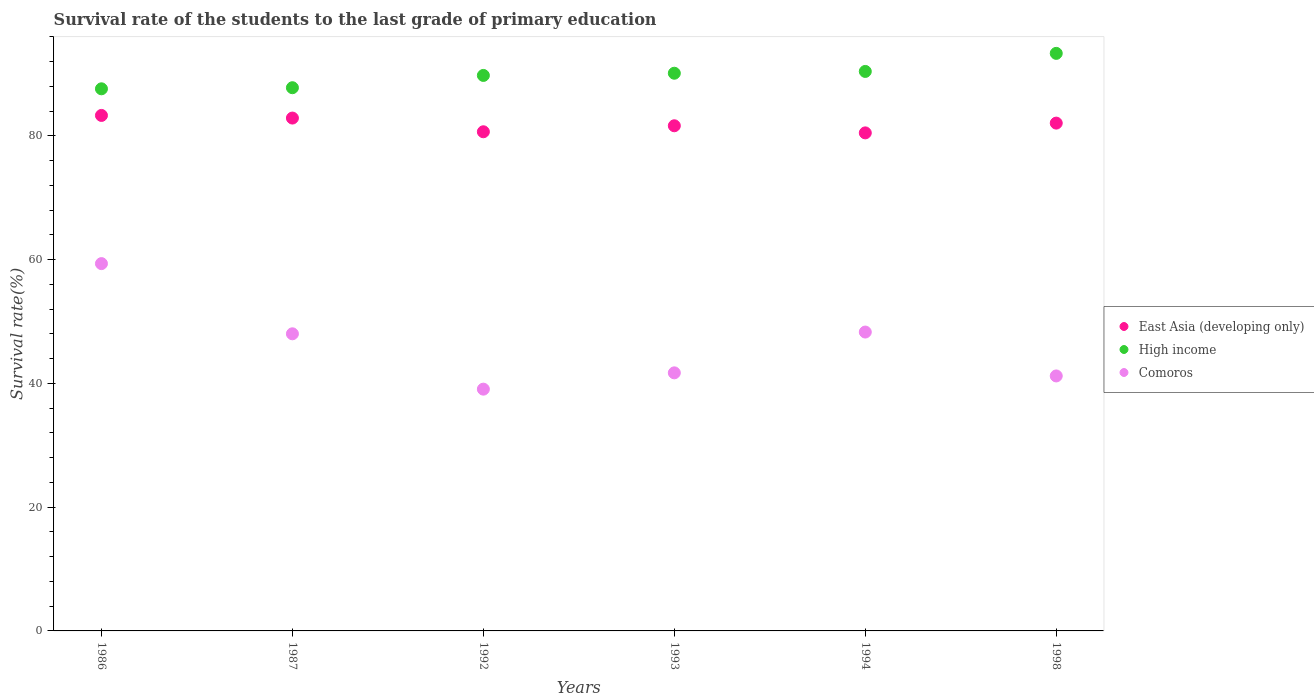What is the survival rate of the students in High income in 1986?
Offer a very short reply. 87.62. Across all years, what is the maximum survival rate of the students in High income?
Your answer should be very brief. 93.35. Across all years, what is the minimum survival rate of the students in East Asia (developing only)?
Ensure brevity in your answer.  80.5. In which year was the survival rate of the students in Comoros maximum?
Keep it short and to the point. 1986. What is the total survival rate of the students in East Asia (developing only) in the graph?
Your answer should be compact. 491.12. What is the difference between the survival rate of the students in East Asia (developing only) in 1987 and that in 1992?
Your answer should be very brief. 2.22. What is the difference between the survival rate of the students in High income in 1992 and the survival rate of the students in East Asia (developing only) in 1986?
Keep it short and to the point. 6.46. What is the average survival rate of the students in East Asia (developing only) per year?
Keep it short and to the point. 81.85. In the year 1986, what is the difference between the survival rate of the students in Comoros and survival rate of the students in East Asia (developing only)?
Offer a very short reply. -23.95. In how many years, is the survival rate of the students in East Asia (developing only) greater than 72 %?
Make the answer very short. 6. What is the ratio of the survival rate of the students in East Asia (developing only) in 1986 to that in 1992?
Make the answer very short. 1.03. Is the survival rate of the students in Comoros in 1987 less than that in 1998?
Provide a succinct answer. No. What is the difference between the highest and the second highest survival rate of the students in Comoros?
Offer a very short reply. 11.06. What is the difference between the highest and the lowest survival rate of the students in East Asia (developing only)?
Offer a very short reply. 2.82. In how many years, is the survival rate of the students in High income greater than the average survival rate of the students in High income taken over all years?
Your answer should be compact. 3. Is the sum of the survival rate of the students in Comoros in 1986 and 1992 greater than the maximum survival rate of the students in East Asia (developing only) across all years?
Offer a very short reply. Yes. Is it the case that in every year, the sum of the survival rate of the students in High income and survival rate of the students in Comoros  is greater than the survival rate of the students in East Asia (developing only)?
Ensure brevity in your answer.  Yes. What is the difference between two consecutive major ticks on the Y-axis?
Keep it short and to the point. 20. Does the graph contain any zero values?
Give a very brief answer. No. Does the graph contain grids?
Your response must be concise. No. How are the legend labels stacked?
Ensure brevity in your answer.  Vertical. What is the title of the graph?
Your response must be concise. Survival rate of the students to the last grade of primary education. What is the label or title of the Y-axis?
Keep it short and to the point. Survival rate(%). What is the Survival rate(%) in East Asia (developing only) in 1986?
Give a very brief answer. 83.32. What is the Survival rate(%) in High income in 1986?
Offer a very short reply. 87.62. What is the Survival rate(%) of Comoros in 1986?
Your answer should be compact. 59.37. What is the Survival rate(%) of East Asia (developing only) in 1987?
Keep it short and to the point. 82.89. What is the Survival rate(%) of High income in 1987?
Keep it short and to the point. 87.8. What is the Survival rate(%) of Comoros in 1987?
Offer a very short reply. 48.02. What is the Survival rate(%) of East Asia (developing only) in 1992?
Keep it short and to the point. 80.68. What is the Survival rate(%) of High income in 1992?
Your response must be concise. 89.79. What is the Survival rate(%) in Comoros in 1992?
Provide a succinct answer. 39.08. What is the Survival rate(%) of East Asia (developing only) in 1993?
Ensure brevity in your answer.  81.65. What is the Survival rate(%) of High income in 1993?
Your answer should be very brief. 90.14. What is the Survival rate(%) in Comoros in 1993?
Your answer should be very brief. 41.71. What is the Survival rate(%) in East Asia (developing only) in 1994?
Offer a very short reply. 80.5. What is the Survival rate(%) of High income in 1994?
Make the answer very short. 90.43. What is the Survival rate(%) in Comoros in 1994?
Give a very brief answer. 48.31. What is the Survival rate(%) of East Asia (developing only) in 1998?
Make the answer very short. 82.08. What is the Survival rate(%) of High income in 1998?
Offer a very short reply. 93.35. What is the Survival rate(%) of Comoros in 1998?
Provide a short and direct response. 41.21. Across all years, what is the maximum Survival rate(%) in East Asia (developing only)?
Your response must be concise. 83.32. Across all years, what is the maximum Survival rate(%) of High income?
Provide a succinct answer. 93.35. Across all years, what is the maximum Survival rate(%) of Comoros?
Your answer should be very brief. 59.37. Across all years, what is the minimum Survival rate(%) in East Asia (developing only)?
Give a very brief answer. 80.5. Across all years, what is the minimum Survival rate(%) in High income?
Give a very brief answer. 87.62. Across all years, what is the minimum Survival rate(%) of Comoros?
Offer a very short reply. 39.08. What is the total Survival rate(%) in East Asia (developing only) in the graph?
Make the answer very short. 491.12. What is the total Survival rate(%) of High income in the graph?
Your response must be concise. 539.14. What is the total Survival rate(%) of Comoros in the graph?
Ensure brevity in your answer.  277.7. What is the difference between the Survival rate(%) in East Asia (developing only) in 1986 and that in 1987?
Ensure brevity in your answer.  0.43. What is the difference between the Survival rate(%) in High income in 1986 and that in 1987?
Your answer should be compact. -0.18. What is the difference between the Survival rate(%) of Comoros in 1986 and that in 1987?
Your answer should be compact. 11.34. What is the difference between the Survival rate(%) of East Asia (developing only) in 1986 and that in 1992?
Offer a very short reply. 2.64. What is the difference between the Survival rate(%) in High income in 1986 and that in 1992?
Provide a succinct answer. -2.16. What is the difference between the Survival rate(%) of Comoros in 1986 and that in 1992?
Your response must be concise. 20.29. What is the difference between the Survival rate(%) of East Asia (developing only) in 1986 and that in 1993?
Offer a terse response. 1.67. What is the difference between the Survival rate(%) of High income in 1986 and that in 1993?
Offer a very short reply. -2.52. What is the difference between the Survival rate(%) in Comoros in 1986 and that in 1993?
Your answer should be compact. 17.66. What is the difference between the Survival rate(%) in East Asia (developing only) in 1986 and that in 1994?
Provide a succinct answer. 2.82. What is the difference between the Survival rate(%) in High income in 1986 and that in 1994?
Your answer should be compact. -2.81. What is the difference between the Survival rate(%) in Comoros in 1986 and that in 1994?
Provide a succinct answer. 11.06. What is the difference between the Survival rate(%) of East Asia (developing only) in 1986 and that in 1998?
Make the answer very short. 1.24. What is the difference between the Survival rate(%) of High income in 1986 and that in 1998?
Provide a succinct answer. -5.73. What is the difference between the Survival rate(%) of Comoros in 1986 and that in 1998?
Your answer should be compact. 18.16. What is the difference between the Survival rate(%) in East Asia (developing only) in 1987 and that in 1992?
Give a very brief answer. 2.22. What is the difference between the Survival rate(%) of High income in 1987 and that in 1992?
Offer a very short reply. -1.99. What is the difference between the Survival rate(%) in Comoros in 1987 and that in 1992?
Give a very brief answer. 8.95. What is the difference between the Survival rate(%) in East Asia (developing only) in 1987 and that in 1993?
Offer a very short reply. 1.24. What is the difference between the Survival rate(%) in High income in 1987 and that in 1993?
Keep it short and to the point. -2.34. What is the difference between the Survival rate(%) of Comoros in 1987 and that in 1993?
Provide a short and direct response. 6.31. What is the difference between the Survival rate(%) in East Asia (developing only) in 1987 and that in 1994?
Provide a succinct answer. 2.4. What is the difference between the Survival rate(%) in High income in 1987 and that in 1994?
Provide a succinct answer. -2.63. What is the difference between the Survival rate(%) of Comoros in 1987 and that in 1994?
Your answer should be very brief. -0.28. What is the difference between the Survival rate(%) in East Asia (developing only) in 1987 and that in 1998?
Ensure brevity in your answer.  0.82. What is the difference between the Survival rate(%) of High income in 1987 and that in 1998?
Your answer should be very brief. -5.55. What is the difference between the Survival rate(%) in Comoros in 1987 and that in 1998?
Keep it short and to the point. 6.81. What is the difference between the Survival rate(%) of East Asia (developing only) in 1992 and that in 1993?
Give a very brief answer. -0.97. What is the difference between the Survival rate(%) in High income in 1992 and that in 1993?
Offer a very short reply. -0.36. What is the difference between the Survival rate(%) of Comoros in 1992 and that in 1993?
Provide a succinct answer. -2.64. What is the difference between the Survival rate(%) in East Asia (developing only) in 1992 and that in 1994?
Ensure brevity in your answer.  0.18. What is the difference between the Survival rate(%) in High income in 1992 and that in 1994?
Your answer should be very brief. -0.65. What is the difference between the Survival rate(%) of Comoros in 1992 and that in 1994?
Provide a succinct answer. -9.23. What is the difference between the Survival rate(%) in East Asia (developing only) in 1992 and that in 1998?
Keep it short and to the point. -1.4. What is the difference between the Survival rate(%) in High income in 1992 and that in 1998?
Provide a succinct answer. -3.57. What is the difference between the Survival rate(%) in Comoros in 1992 and that in 1998?
Offer a terse response. -2.14. What is the difference between the Survival rate(%) in East Asia (developing only) in 1993 and that in 1994?
Provide a short and direct response. 1.15. What is the difference between the Survival rate(%) in High income in 1993 and that in 1994?
Provide a short and direct response. -0.29. What is the difference between the Survival rate(%) of Comoros in 1993 and that in 1994?
Your answer should be very brief. -6.59. What is the difference between the Survival rate(%) of East Asia (developing only) in 1993 and that in 1998?
Your answer should be compact. -0.43. What is the difference between the Survival rate(%) of High income in 1993 and that in 1998?
Offer a very short reply. -3.21. What is the difference between the Survival rate(%) of Comoros in 1993 and that in 1998?
Ensure brevity in your answer.  0.5. What is the difference between the Survival rate(%) in East Asia (developing only) in 1994 and that in 1998?
Your answer should be very brief. -1.58. What is the difference between the Survival rate(%) in High income in 1994 and that in 1998?
Provide a short and direct response. -2.92. What is the difference between the Survival rate(%) of Comoros in 1994 and that in 1998?
Offer a very short reply. 7.1. What is the difference between the Survival rate(%) in East Asia (developing only) in 1986 and the Survival rate(%) in High income in 1987?
Give a very brief answer. -4.48. What is the difference between the Survival rate(%) in East Asia (developing only) in 1986 and the Survival rate(%) in Comoros in 1987?
Give a very brief answer. 35.3. What is the difference between the Survival rate(%) in High income in 1986 and the Survival rate(%) in Comoros in 1987?
Offer a terse response. 39.6. What is the difference between the Survival rate(%) in East Asia (developing only) in 1986 and the Survival rate(%) in High income in 1992?
Provide a succinct answer. -6.46. What is the difference between the Survival rate(%) in East Asia (developing only) in 1986 and the Survival rate(%) in Comoros in 1992?
Your answer should be compact. 44.24. What is the difference between the Survival rate(%) of High income in 1986 and the Survival rate(%) of Comoros in 1992?
Offer a terse response. 48.55. What is the difference between the Survival rate(%) in East Asia (developing only) in 1986 and the Survival rate(%) in High income in 1993?
Ensure brevity in your answer.  -6.82. What is the difference between the Survival rate(%) of East Asia (developing only) in 1986 and the Survival rate(%) of Comoros in 1993?
Keep it short and to the point. 41.61. What is the difference between the Survival rate(%) in High income in 1986 and the Survival rate(%) in Comoros in 1993?
Your answer should be compact. 45.91. What is the difference between the Survival rate(%) of East Asia (developing only) in 1986 and the Survival rate(%) of High income in 1994?
Your answer should be compact. -7.11. What is the difference between the Survival rate(%) in East Asia (developing only) in 1986 and the Survival rate(%) in Comoros in 1994?
Offer a very short reply. 35.01. What is the difference between the Survival rate(%) in High income in 1986 and the Survival rate(%) in Comoros in 1994?
Make the answer very short. 39.32. What is the difference between the Survival rate(%) in East Asia (developing only) in 1986 and the Survival rate(%) in High income in 1998?
Your answer should be compact. -10.03. What is the difference between the Survival rate(%) in East Asia (developing only) in 1986 and the Survival rate(%) in Comoros in 1998?
Offer a very short reply. 42.11. What is the difference between the Survival rate(%) in High income in 1986 and the Survival rate(%) in Comoros in 1998?
Make the answer very short. 46.41. What is the difference between the Survival rate(%) of East Asia (developing only) in 1987 and the Survival rate(%) of High income in 1992?
Offer a terse response. -6.89. What is the difference between the Survival rate(%) in East Asia (developing only) in 1987 and the Survival rate(%) in Comoros in 1992?
Provide a succinct answer. 43.82. What is the difference between the Survival rate(%) in High income in 1987 and the Survival rate(%) in Comoros in 1992?
Provide a succinct answer. 48.72. What is the difference between the Survival rate(%) in East Asia (developing only) in 1987 and the Survival rate(%) in High income in 1993?
Your answer should be compact. -7.25. What is the difference between the Survival rate(%) in East Asia (developing only) in 1987 and the Survival rate(%) in Comoros in 1993?
Provide a succinct answer. 41.18. What is the difference between the Survival rate(%) in High income in 1987 and the Survival rate(%) in Comoros in 1993?
Offer a very short reply. 46.09. What is the difference between the Survival rate(%) of East Asia (developing only) in 1987 and the Survival rate(%) of High income in 1994?
Keep it short and to the point. -7.54. What is the difference between the Survival rate(%) in East Asia (developing only) in 1987 and the Survival rate(%) in Comoros in 1994?
Ensure brevity in your answer.  34.59. What is the difference between the Survival rate(%) in High income in 1987 and the Survival rate(%) in Comoros in 1994?
Provide a succinct answer. 39.49. What is the difference between the Survival rate(%) of East Asia (developing only) in 1987 and the Survival rate(%) of High income in 1998?
Your answer should be very brief. -10.46. What is the difference between the Survival rate(%) of East Asia (developing only) in 1987 and the Survival rate(%) of Comoros in 1998?
Your response must be concise. 41.68. What is the difference between the Survival rate(%) of High income in 1987 and the Survival rate(%) of Comoros in 1998?
Provide a short and direct response. 46.59. What is the difference between the Survival rate(%) in East Asia (developing only) in 1992 and the Survival rate(%) in High income in 1993?
Your response must be concise. -9.46. What is the difference between the Survival rate(%) of East Asia (developing only) in 1992 and the Survival rate(%) of Comoros in 1993?
Keep it short and to the point. 38.97. What is the difference between the Survival rate(%) of High income in 1992 and the Survival rate(%) of Comoros in 1993?
Your answer should be compact. 48.07. What is the difference between the Survival rate(%) of East Asia (developing only) in 1992 and the Survival rate(%) of High income in 1994?
Your response must be concise. -9.75. What is the difference between the Survival rate(%) of East Asia (developing only) in 1992 and the Survival rate(%) of Comoros in 1994?
Your answer should be compact. 32.37. What is the difference between the Survival rate(%) in High income in 1992 and the Survival rate(%) in Comoros in 1994?
Offer a very short reply. 41.48. What is the difference between the Survival rate(%) in East Asia (developing only) in 1992 and the Survival rate(%) in High income in 1998?
Your response must be concise. -12.67. What is the difference between the Survival rate(%) in East Asia (developing only) in 1992 and the Survival rate(%) in Comoros in 1998?
Offer a very short reply. 39.47. What is the difference between the Survival rate(%) of High income in 1992 and the Survival rate(%) of Comoros in 1998?
Offer a very short reply. 48.57. What is the difference between the Survival rate(%) in East Asia (developing only) in 1993 and the Survival rate(%) in High income in 1994?
Ensure brevity in your answer.  -8.78. What is the difference between the Survival rate(%) of East Asia (developing only) in 1993 and the Survival rate(%) of Comoros in 1994?
Give a very brief answer. 33.34. What is the difference between the Survival rate(%) in High income in 1993 and the Survival rate(%) in Comoros in 1994?
Make the answer very short. 41.83. What is the difference between the Survival rate(%) in East Asia (developing only) in 1993 and the Survival rate(%) in High income in 1998?
Provide a succinct answer. -11.7. What is the difference between the Survival rate(%) in East Asia (developing only) in 1993 and the Survival rate(%) in Comoros in 1998?
Keep it short and to the point. 40.44. What is the difference between the Survival rate(%) of High income in 1993 and the Survival rate(%) of Comoros in 1998?
Give a very brief answer. 48.93. What is the difference between the Survival rate(%) in East Asia (developing only) in 1994 and the Survival rate(%) in High income in 1998?
Offer a terse response. -12.85. What is the difference between the Survival rate(%) of East Asia (developing only) in 1994 and the Survival rate(%) of Comoros in 1998?
Your answer should be compact. 39.29. What is the difference between the Survival rate(%) in High income in 1994 and the Survival rate(%) in Comoros in 1998?
Provide a succinct answer. 49.22. What is the average Survival rate(%) of East Asia (developing only) per year?
Your response must be concise. 81.85. What is the average Survival rate(%) in High income per year?
Ensure brevity in your answer.  89.86. What is the average Survival rate(%) of Comoros per year?
Make the answer very short. 46.28. In the year 1986, what is the difference between the Survival rate(%) in East Asia (developing only) and Survival rate(%) in High income?
Your response must be concise. -4.3. In the year 1986, what is the difference between the Survival rate(%) of East Asia (developing only) and Survival rate(%) of Comoros?
Your answer should be very brief. 23.95. In the year 1986, what is the difference between the Survival rate(%) in High income and Survival rate(%) in Comoros?
Offer a very short reply. 28.25. In the year 1987, what is the difference between the Survival rate(%) in East Asia (developing only) and Survival rate(%) in High income?
Ensure brevity in your answer.  -4.9. In the year 1987, what is the difference between the Survival rate(%) in East Asia (developing only) and Survival rate(%) in Comoros?
Offer a very short reply. 34.87. In the year 1987, what is the difference between the Survival rate(%) of High income and Survival rate(%) of Comoros?
Your answer should be compact. 39.78. In the year 1992, what is the difference between the Survival rate(%) in East Asia (developing only) and Survival rate(%) in High income?
Ensure brevity in your answer.  -9.11. In the year 1992, what is the difference between the Survival rate(%) of East Asia (developing only) and Survival rate(%) of Comoros?
Keep it short and to the point. 41.6. In the year 1992, what is the difference between the Survival rate(%) in High income and Survival rate(%) in Comoros?
Make the answer very short. 50.71. In the year 1993, what is the difference between the Survival rate(%) of East Asia (developing only) and Survival rate(%) of High income?
Make the answer very short. -8.49. In the year 1993, what is the difference between the Survival rate(%) of East Asia (developing only) and Survival rate(%) of Comoros?
Provide a succinct answer. 39.94. In the year 1993, what is the difference between the Survival rate(%) in High income and Survival rate(%) in Comoros?
Provide a short and direct response. 48.43. In the year 1994, what is the difference between the Survival rate(%) in East Asia (developing only) and Survival rate(%) in High income?
Provide a short and direct response. -9.93. In the year 1994, what is the difference between the Survival rate(%) in East Asia (developing only) and Survival rate(%) in Comoros?
Your response must be concise. 32.19. In the year 1994, what is the difference between the Survival rate(%) in High income and Survival rate(%) in Comoros?
Give a very brief answer. 42.12. In the year 1998, what is the difference between the Survival rate(%) of East Asia (developing only) and Survival rate(%) of High income?
Give a very brief answer. -11.27. In the year 1998, what is the difference between the Survival rate(%) in East Asia (developing only) and Survival rate(%) in Comoros?
Offer a terse response. 40.87. In the year 1998, what is the difference between the Survival rate(%) of High income and Survival rate(%) of Comoros?
Provide a succinct answer. 52.14. What is the ratio of the Survival rate(%) in East Asia (developing only) in 1986 to that in 1987?
Your answer should be compact. 1.01. What is the ratio of the Survival rate(%) in Comoros in 1986 to that in 1987?
Provide a succinct answer. 1.24. What is the ratio of the Survival rate(%) of East Asia (developing only) in 1986 to that in 1992?
Offer a terse response. 1.03. What is the ratio of the Survival rate(%) of High income in 1986 to that in 1992?
Provide a short and direct response. 0.98. What is the ratio of the Survival rate(%) of Comoros in 1986 to that in 1992?
Offer a very short reply. 1.52. What is the ratio of the Survival rate(%) of East Asia (developing only) in 1986 to that in 1993?
Your answer should be very brief. 1.02. What is the ratio of the Survival rate(%) of High income in 1986 to that in 1993?
Make the answer very short. 0.97. What is the ratio of the Survival rate(%) in Comoros in 1986 to that in 1993?
Offer a terse response. 1.42. What is the ratio of the Survival rate(%) in East Asia (developing only) in 1986 to that in 1994?
Make the answer very short. 1.03. What is the ratio of the Survival rate(%) in High income in 1986 to that in 1994?
Provide a short and direct response. 0.97. What is the ratio of the Survival rate(%) in Comoros in 1986 to that in 1994?
Provide a succinct answer. 1.23. What is the ratio of the Survival rate(%) in East Asia (developing only) in 1986 to that in 1998?
Offer a terse response. 1.02. What is the ratio of the Survival rate(%) in High income in 1986 to that in 1998?
Give a very brief answer. 0.94. What is the ratio of the Survival rate(%) in Comoros in 1986 to that in 1998?
Keep it short and to the point. 1.44. What is the ratio of the Survival rate(%) of East Asia (developing only) in 1987 to that in 1992?
Make the answer very short. 1.03. What is the ratio of the Survival rate(%) of High income in 1987 to that in 1992?
Your answer should be compact. 0.98. What is the ratio of the Survival rate(%) of Comoros in 1987 to that in 1992?
Your answer should be very brief. 1.23. What is the ratio of the Survival rate(%) of East Asia (developing only) in 1987 to that in 1993?
Your answer should be compact. 1.02. What is the ratio of the Survival rate(%) of High income in 1987 to that in 1993?
Provide a short and direct response. 0.97. What is the ratio of the Survival rate(%) of Comoros in 1987 to that in 1993?
Make the answer very short. 1.15. What is the ratio of the Survival rate(%) of East Asia (developing only) in 1987 to that in 1994?
Keep it short and to the point. 1.03. What is the ratio of the Survival rate(%) of High income in 1987 to that in 1994?
Make the answer very short. 0.97. What is the ratio of the Survival rate(%) in East Asia (developing only) in 1987 to that in 1998?
Ensure brevity in your answer.  1.01. What is the ratio of the Survival rate(%) in High income in 1987 to that in 1998?
Offer a very short reply. 0.94. What is the ratio of the Survival rate(%) of Comoros in 1987 to that in 1998?
Offer a terse response. 1.17. What is the ratio of the Survival rate(%) in Comoros in 1992 to that in 1993?
Your answer should be compact. 0.94. What is the ratio of the Survival rate(%) of East Asia (developing only) in 1992 to that in 1994?
Your answer should be compact. 1. What is the ratio of the Survival rate(%) of High income in 1992 to that in 1994?
Give a very brief answer. 0.99. What is the ratio of the Survival rate(%) of Comoros in 1992 to that in 1994?
Offer a very short reply. 0.81. What is the ratio of the Survival rate(%) in East Asia (developing only) in 1992 to that in 1998?
Your answer should be compact. 0.98. What is the ratio of the Survival rate(%) of High income in 1992 to that in 1998?
Make the answer very short. 0.96. What is the ratio of the Survival rate(%) of Comoros in 1992 to that in 1998?
Your response must be concise. 0.95. What is the ratio of the Survival rate(%) of East Asia (developing only) in 1993 to that in 1994?
Give a very brief answer. 1.01. What is the ratio of the Survival rate(%) of Comoros in 1993 to that in 1994?
Your answer should be very brief. 0.86. What is the ratio of the Survival rate(%) in High income in 1993 to that in 1998?
Make the answer very short. 0.97. What is the ratio of the Survival rate(%) of Comoros in 1993 to that in 1998?
Offer a terse response. 1.01. What is the ratio of the Survival rate(%) in East Asia (developing only) in 1994 to that in 1998?
Your response must be concise. 0.98. What is the ratio of the Survival rate(%) of High income in 1994 to that in 1998?
Offer a terse response. 0.97. What is the ratio of the Survival rate(%) of Comoros in 1994 to that in 1998?
Keep it short and to the point. 1.17. What is the difference between the highest and the second highest Survival rate(%) in East Asia (developing only)?
Provide a short and direct response. 0.43. What is the difference between the highest and the second highest Survival rate(%) in High income?
Offer a very short reply. 2.92. What is the difference between the highest and the second highest Survival rate(%) of Comoros?
Provide a short and direct response. 11.06. What is the difference between the highest and the lowest Survival rate(%) of East Asia (developing only)?
Provide a succinct answer. 2.82. What is the difference between the highest and the lowest Survival rate(%) in High income?
Ensure brevity in your answer.  5.73. What is the difference between the highest and the lowest Survival rate(%) of Comoros?
Keep it short and to the point. 20.29. 